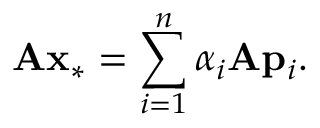Convert formula to latex. <formula><loc_0><loc_0><loc_500><loc_500>A x _ { * } = \sum _ { i = 1 } ^ { n } \alpha _ { i } A p _ { i } .</formula> 